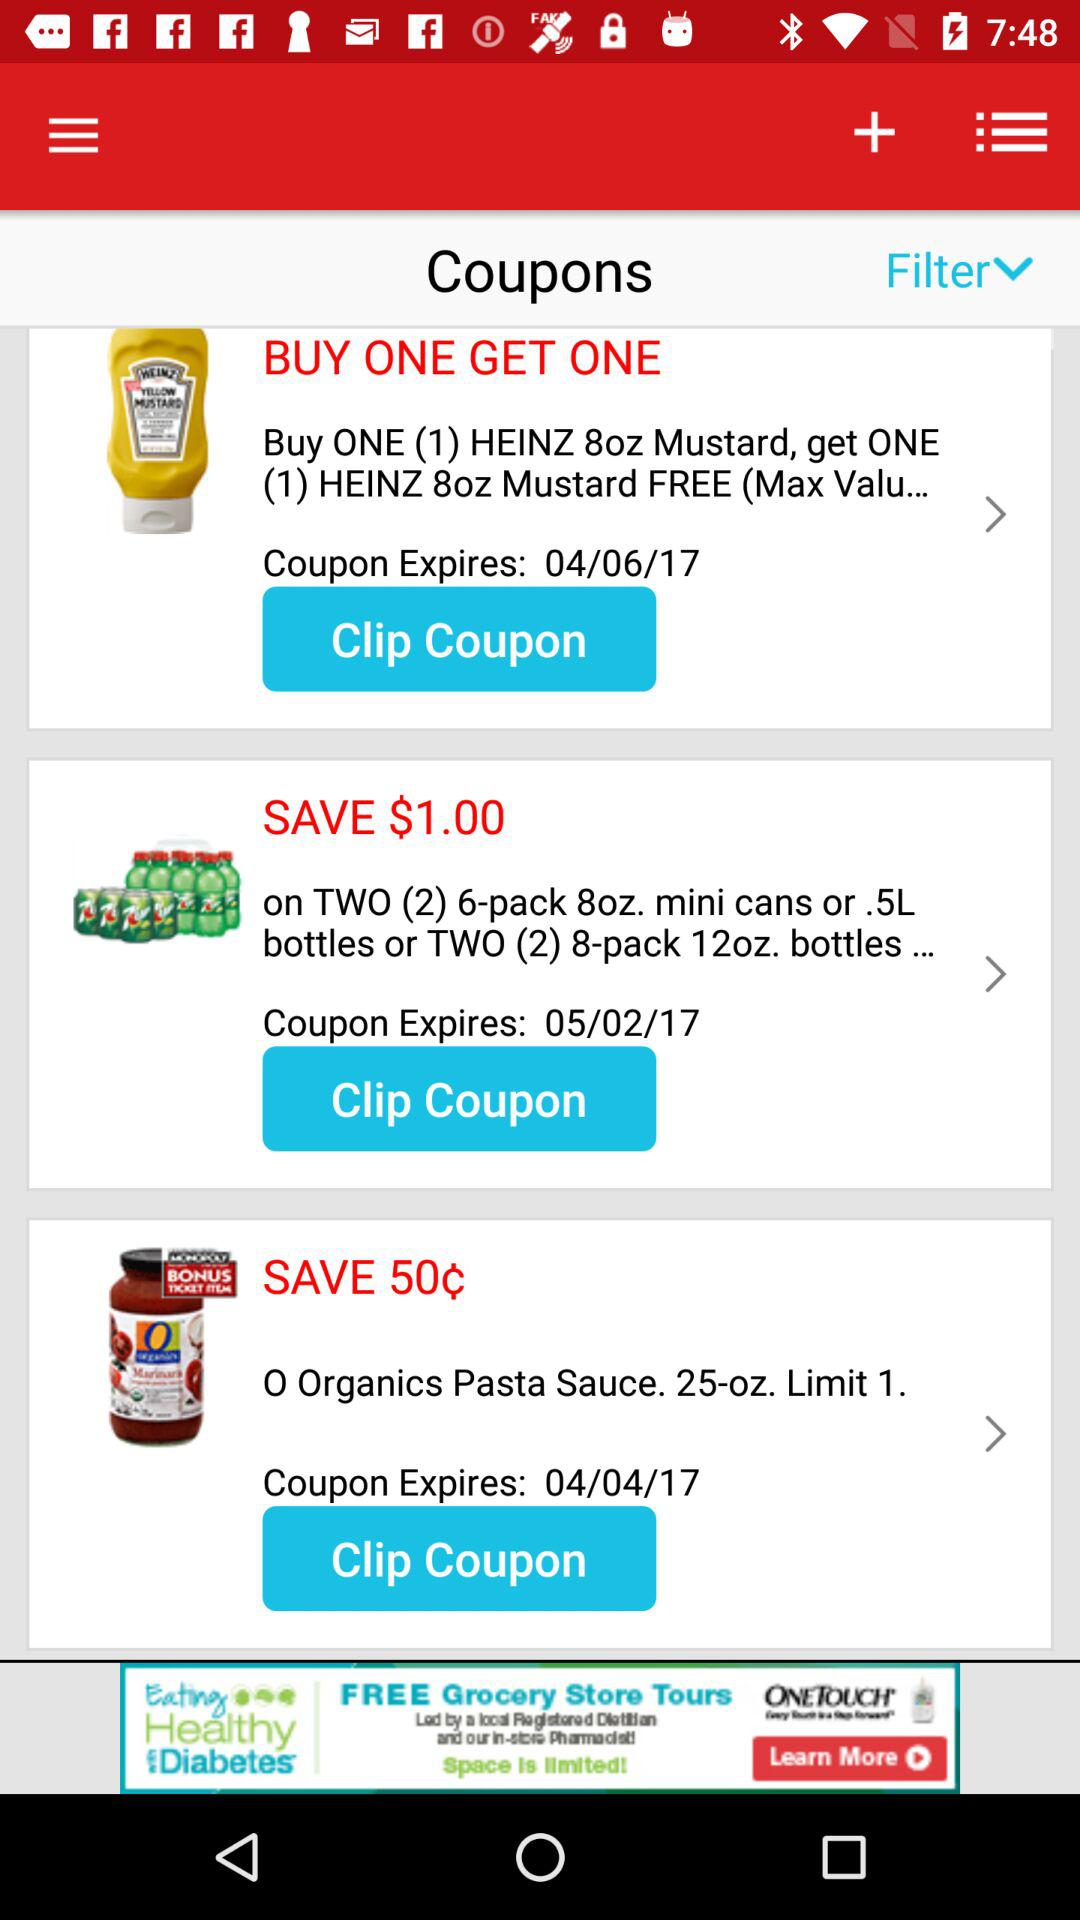When will the coupon expire for "HEINZ 8oz Mustard"? The coupon will expire on April 06, 2017. 